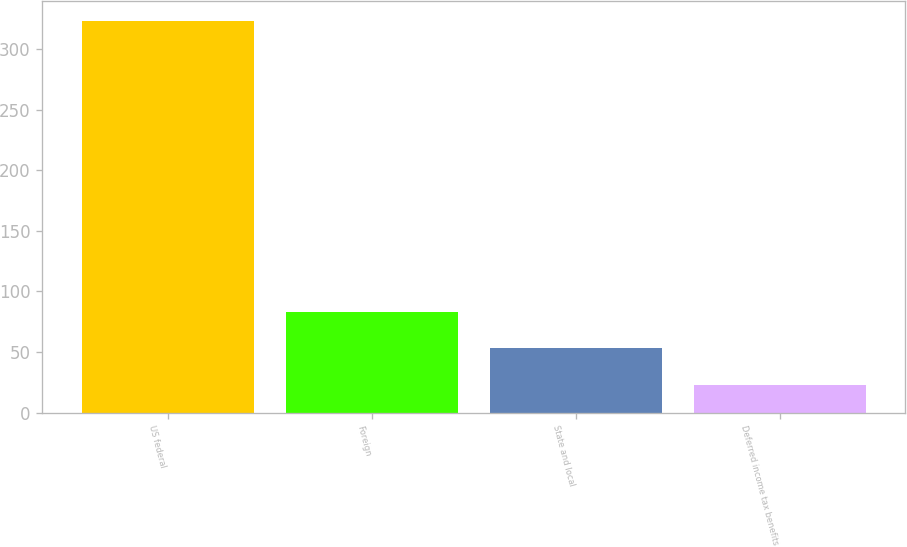Convert chart. <chart><loc_0><loc_0><loc_500><loc_500><bar_chart><fcel>US federal<fcel>Foreign<fcel>State and local<fcel>Deferred income tax benefits<nl><fcel>323.4<fcel>83.24<fcel>53.22<fcel>23.2<nl></chart> 